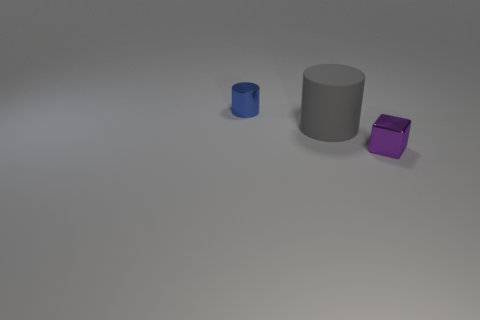Subtract 1 cubes. How many cubes are left? 0 Subtract all cubes. How many objects are left? 2 Subtract all brown cylinders. Subtract all purple spheres. How many cylinders are left? 2 Subtract all red blocks. How many yellow cylinders are left? 0 Subtract all blue things. Subtract all big purple cylinders. How many objects are left? 2 Add 3 tiny blocks. How many tiny blocks are left? 4 Add 3 tiny blue things. How many tiny blue things exist? 4 Add 3 small purple things. How many objects exist? 6 Subtract all blue cylinders. How many cylinders are left? 1 Subtract 0 red cylinders. How many objects are left? 3 